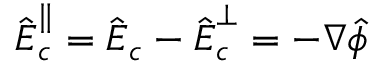<formula> <loc_0><loc_0><loc_500><loc_500>\hat { \boldsymbol E } _ { c } ^ { \| } = \hat { \boldsymbol E } _ { c } - \hat { \boldsymbol E } _ { c } ^ { \perp } = - \boldsymbol \nabla \hat { \phi }</formula> 